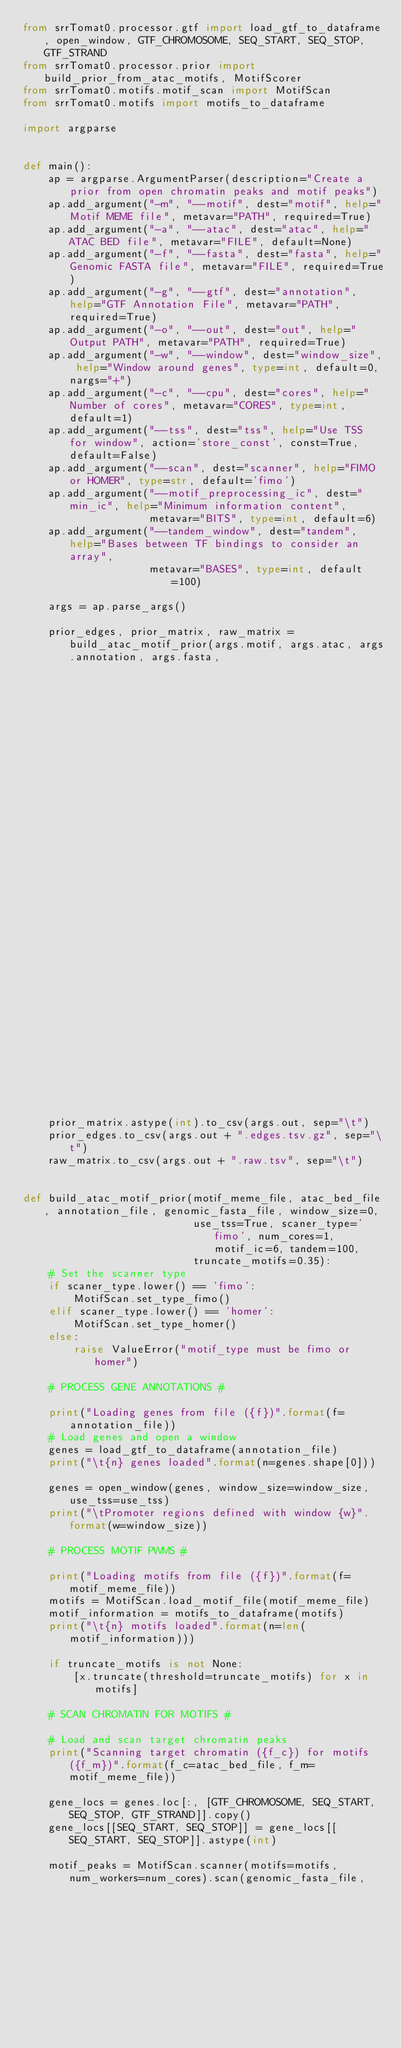<code> <loc_0><loc_0><loc_500><loc_500><_Python_>from srrTomat0.processor.gtf import load_gtf_to_dataframe, open_window, GTF_CHROMOSOME, SEQ_START, SEQ_STOP, GTF_STRAND
from srrTomat0.processor.prior import build_prior_from_atac_motifs, MotifScorer
from srrTomat0.motifs.motif_scan import MotifScan
from srrTomat0.motifs import motifs_to_dataframe

import argparse


def main():
    ap = argparse.ArgumentParser(description="Create a prior from open chromatin peaks and motif peaks")
    ap.add_argument("-m", "--motif", dest="motif", help="Motif MEME file", metavar="PATH", required=True)
    ap.add_argument("-a", "--atac", dest="atac", help="ATAC BED file", metavar="FILE", default=None)
    ap.add_argument("-f", "--fasta", dest="fasta", help="Genomic FASTA file", metavar="FILE", required=True)
    ap.add_argument("-g", "--gtf", dest="annotation", help="GTF Annotation File", metavar="PATH", required=True)
    ap.add_argument("-o", "--out", dest="out", help="Output PATH", metavar="PATH", required=True)
    ap.add_argument("-w", "--window", dest="window_size", help="Window around genes", type=int, default=0, nargs="+")
    ap.add_argument("-c", "--cpu", dest="cores", help="Number of cores", metavar="CORES", type=int, default=1)
    ap.add_argument("--tss", dest="tss", help="Use TSS for window", action='store_const', const=True, default=False)
    ap.add_argument("--scan", dest="scanner", help="FIMO or HOMER", type=str, default='fimo')
    ap.add_argument("--motif_preprocessing_ic", dest="min_ic", help="Minimum information content",
                    metavar="BITS", type=int, default=6)
    ap.add_argument("--tandem_window", dest="tandem", help="Bases between TF bindings to consider an array",
                    metavar="BASES", type=int, default=100)

    args = ap.parse_args()

    prior_edges, prior_matrix, raw_matrix = build_atac_motif_prior(args.motif, args.atac, args.annotation, args.fasta,
                                                                   window_size=args.window_size, num_cores=args.cores,
                                                                   use_tss=args.tss, motif_ic=args.min_ic,
                                                                   scaner_type=args.scanner)

    prior_matrix.astype(int).to_csv(args.out, sep="\t")
    prior_edges.to_csv(args.out + ".edges.tsv.gz", sep="\t")
    raw_matrix.to_csv(args.out + ".raw.tsv", sep="\t")


def build_atac_motif_prior(motif_meme_file, atac_bed_file, annotation_file, genomic_fasta_file, window_size=0,
                           use_tss=True, scaner_type='fimo', num_cores=1, motif_ic=6, tandem=100,
                           truncate_motifs=0.35):
    # Set the scanner type
    if scaner_type.lower() == 'fimo':
        MotifScan.set_type_fimo()
    elif scaner_type.lower() == 'homer':
        MotifScan.set_type_homer()
    else:
        raise ValueError("motif_type must be fimo or homer")

    # PROCESS GENE ANNOTATIONS #

    print("Loading genes from file ({f})".format(f=annotation_file))
    # Load genes and open a window
    genes = load_gtf_to_dataframe(annotation_file)
    print("\t{n} genes loaded".format(n=genes.shape[0]))

    genes = open_window(genes, window_size=window_size, use_tss=use_tss)
    print("\tPromoter regions defined with window {w}".format(w=window_size))

    # PROCESS MOTIF PWMS #

    print("Loading motifs from file ({f})".format(f=motif_meme_file))
    motifs = MotifScan.load_motif_file(motif_meme_file)
    motif_information = motifs_to_dataframe(motifs)
    print("\t{n} motifs loaded".format(n=len(motif_information)))

    if truncate_motifs is not None:
        [x.truncate(threshold=truncate_motifs) for x in motifs]

    # SCAN CHROMATIN FOR MOTIFS #

    # Load and scan target chromatin peaks
    print("Scanning target chromatin ({f_c}) for motifs ({f_m})".format(f_c=atac_bed_file, f_m=motif_meme_file))

    gene_locs = genes.loc[:, [GTF_CHROMOSOME, SEQ_START, SEQ_STOP, GTF_STRAND]].copy()
    gene_locs[[SEQ_START, SEQ_STOP]] = gene_locs[[SEQ_START, SEQ_STOP]].astype(int)

    motif_peaks = MotifScan.scanner(motifs=motifs, num_workers=num_cores).scan(genomic_fasta_file,
                                                                               atac_bed_file=atac_bed_file,
                                                                               promoter_bed=gene_locs,</code> 